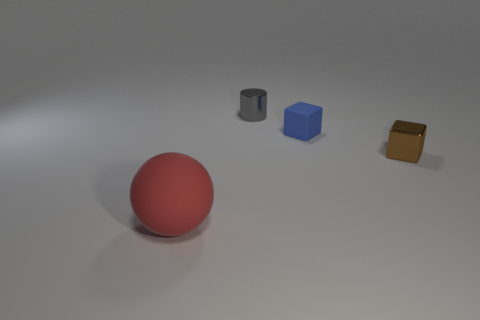Add 1 small gray things. How many objects exist? 5 Subtract all spheres. How many objects are left? 3 Subtract 0 brown spheres. How many objects are left? 4 Subtract all matte spheres. Subtract all cubes. How many objects are left? 1 Add 3 large red spheres. How many large red spheres are left? 4 Add 4 small gray objects. How many small gray objects exist? 5 